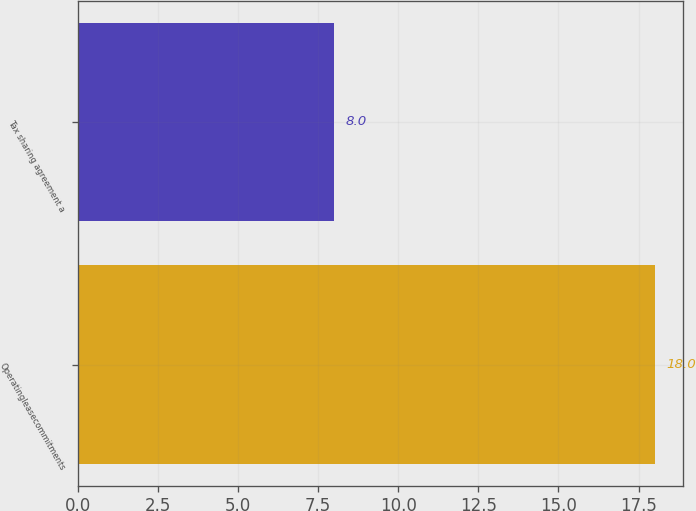<chart> <loc_0><loc_0><loc_500><loc_500><bar_chart><fcel>Operatingleasecommitments<fcel>Tax sharing agreement a<nl><fcel>18<fcel>8<nl></chart> 